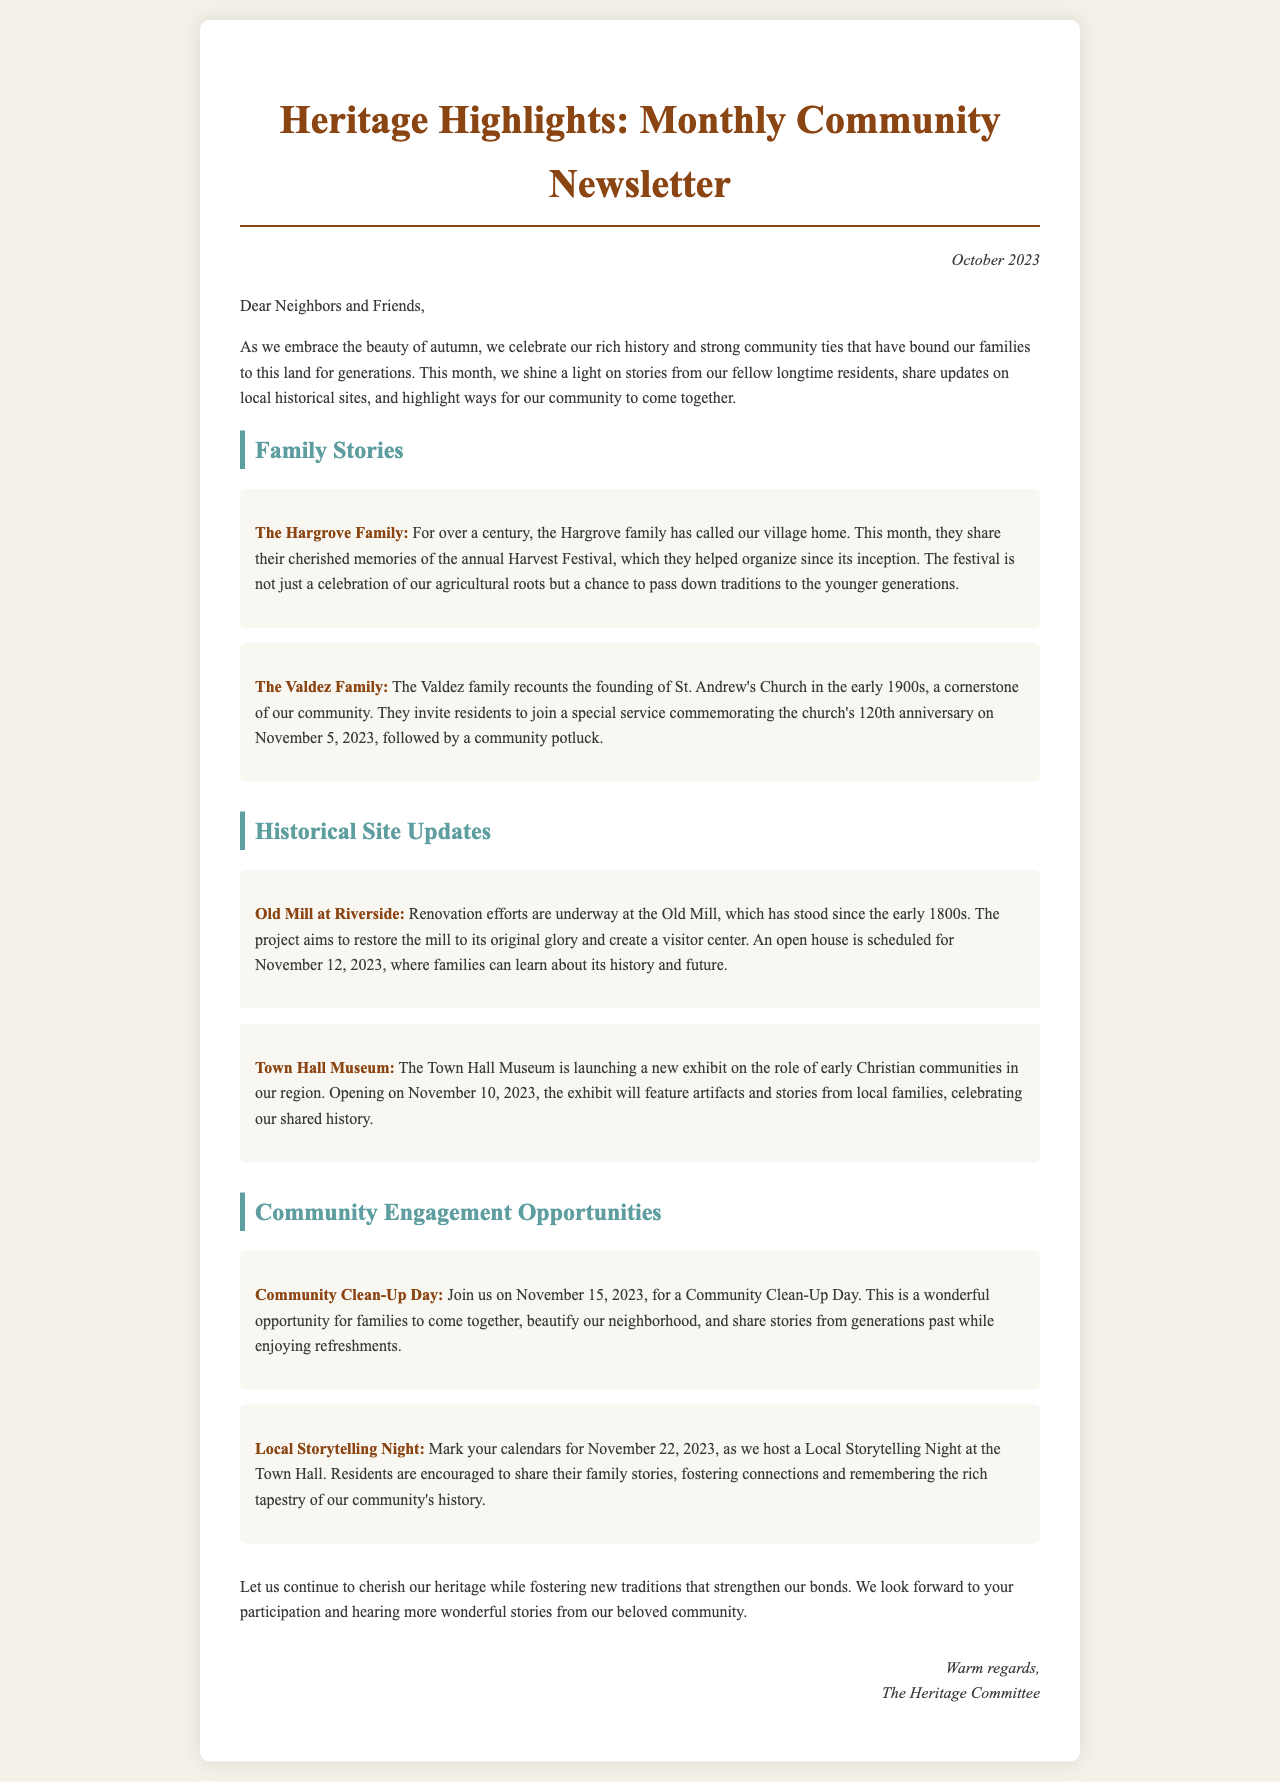What is the title of the newsletter? The title of the newsletter is presented at the top and is "Heritage Highlights: Monthly Community Newsletter."
Answer: Heritage Highlights: Monthly Community Newsletter Who is sharing memories about the Harvest Festival? The Hargrove family is sharing their cherished memories of the annual Harvest Festival.
Answer: The Hargrove Family What date is the commemoration service for St. Andrew's Church? The letter states that the service is on November 5, 2023.
Answer: November 5, 2023 When is the open house for the Old Mill at Riverside? The open house is scheduled for November 12, 2023.
Answer: November 12, 2023 What type of event is scheduled for November 15, 2023? The event on November 15, 2023, is a Community Clean-Up Day.
Answer: Community Clean-Up Day Which historical site is launching a new exhibit? The Town Hall Museum is launching a new exhibit on early Christian communities.
Answer: Town Hall Museum What is the purpose of the Local Storytelling Night? Residents are encouraged to share their family stories during the Local Storytelling Night.
Answer: Share family stories How many generations have the Hargrove family lived in the area? The Hargrove family has lived in the area for over a century.
Answer: Over a century What are participants going to do during the Community Clean-Up Day? Participants during the Community Clean-Up Day will beautify the neighborhood and share stories.
Answer: Beautify the neighborhood and share stories 